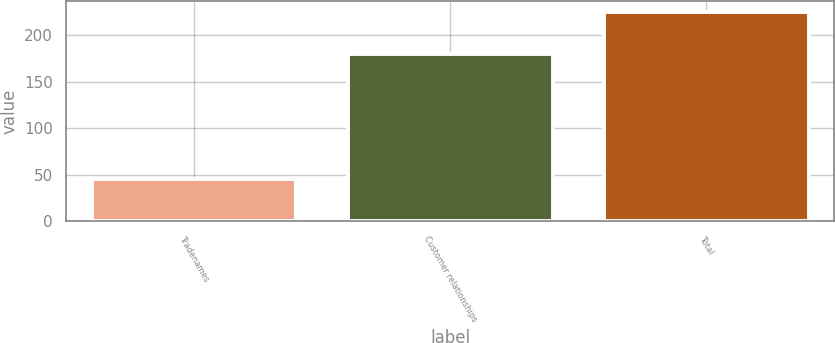Convert chart. <chart><loc_0><loc_0><loc_500><loc_500><bar_chart><fcel>Tradenames<fcel>Customer relationships<fcel>Total<nl><fcel>45<fcel>180<fcel>225<nl></chart> 